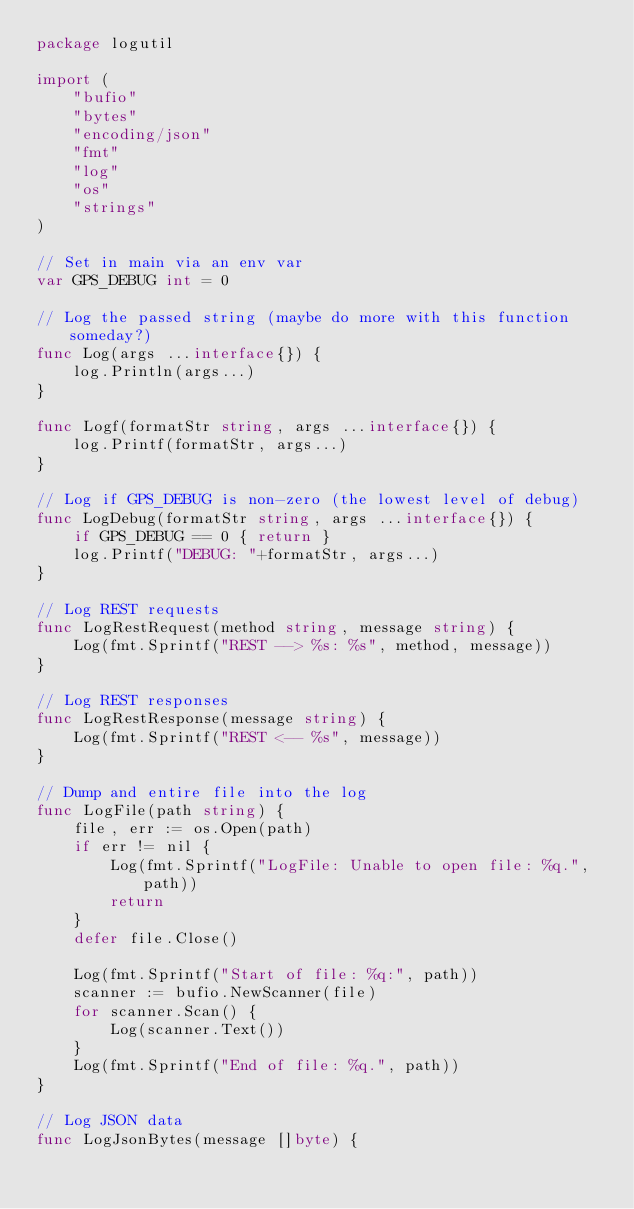Convert code to text. <code><loc_0><loc_0><loc_500><loc_500><_Go_>package logutil

import (
	"bufio"
	"bytes"
	"encoding/json"
	"fmt"
	"log"
	"os"
	"strings"
)

// Set in main via an env var
var GPS_DEBUG int = 0

// Log the passed string (maybe do more with this function someday?)
func Log(args ...interface{}) {
	log.Println(args...)
}

func Logf(formatStr string, args ...interface{}) {
	log.Printf(formatStr, args...)
}

// Log if GPS_DEBUG is non-zero (the lowest level of debug)
func LogDebug(formatStr string, args ...interface{}) {
	if GPS_DEBUG == 0 { return }
	log.Printf("DEBUG: "+formatStr, args...)
}

// Log REST requests
func LogRestRequest(method string, message string) {
	Log(fmt.Sprintf("REST --> %s: %s", method, message))
}

// Log REST responses
func LogRestResponse(message string) {
	Log(fmt.Sprintf("REST <-- %s", message))
}

// Dump and entire file into the log
func LogFile(path string) {
	file, err := os.Open(path)
	if err != nil {
		Log(fmt.Sprintf("LogFile: Unable to open file: %q.", path))
		return
	}
	defer file.Close()

	Log(fmt.Sprintf("Start of file: %q:", path))
	scanner := bufio.NewScanner(file)
	for scanner.Scan() {
		Log(scanner.Text())
	}
	Log(fmt.Sprintf("End of file: %q.", path))
}

// Log JSON data
func LogJsonBytes(message []byte) {</code> 